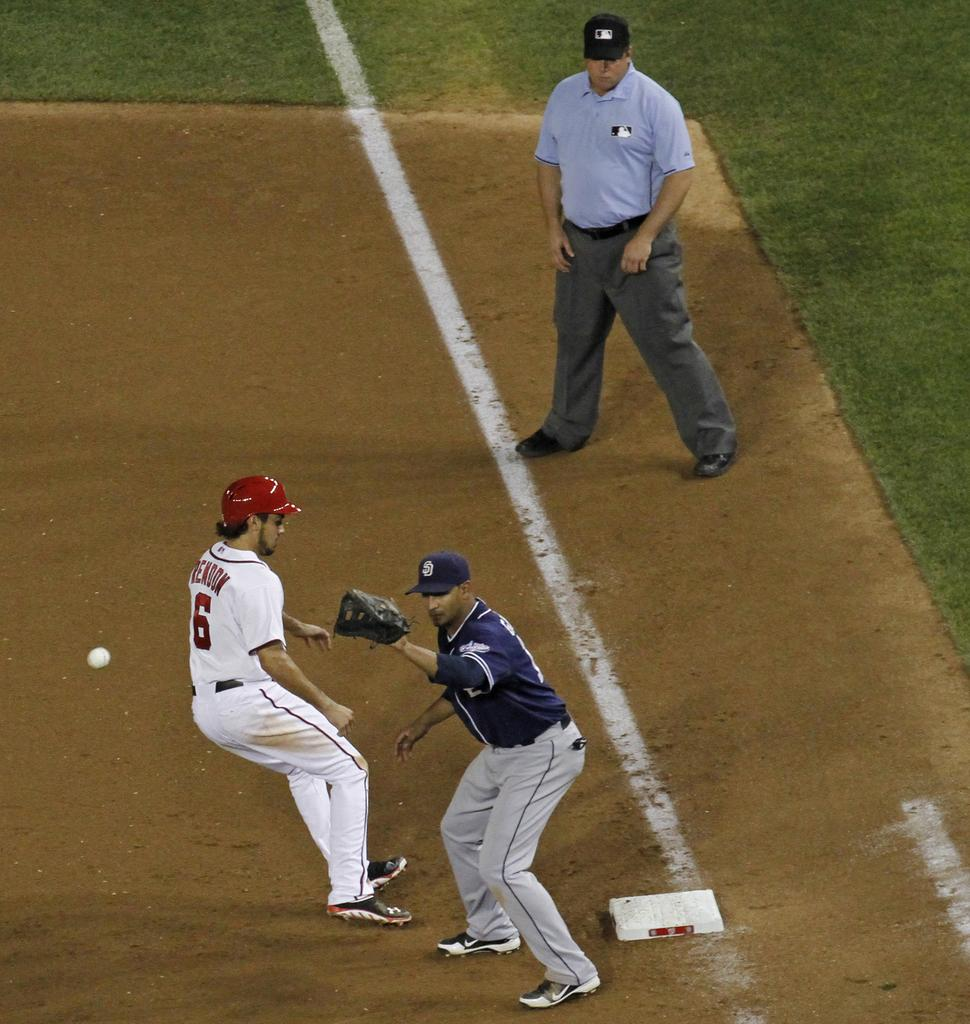<image>
Describe the image concisely. Player number 6 is racing to the base as the ball comes in for a catch. 